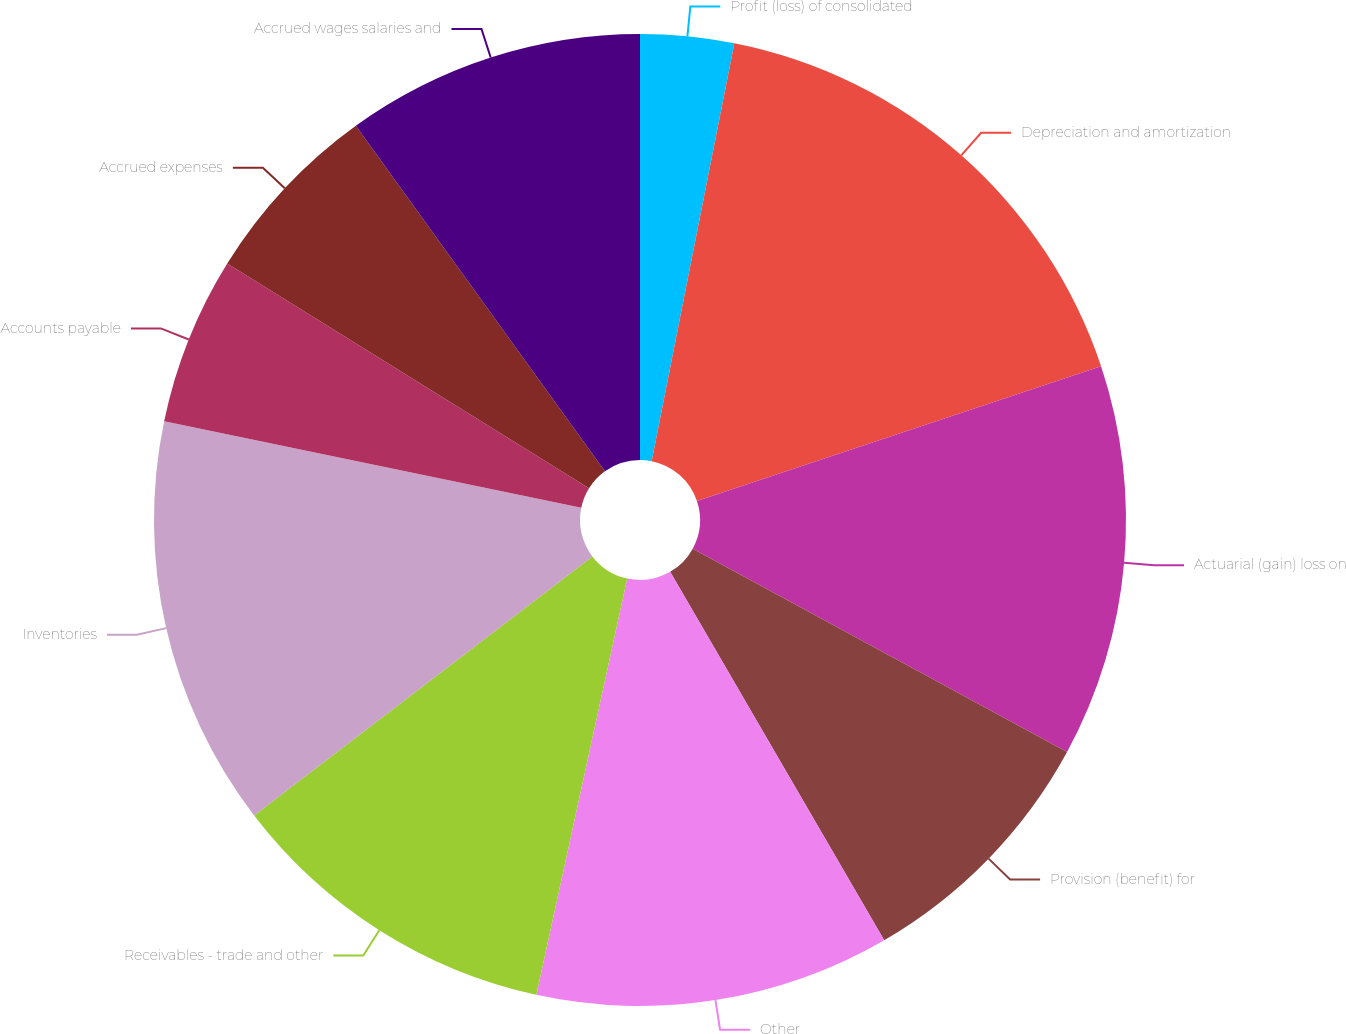Convert chart. <chart><loc_0><loc_0><loc_500><loc_500><pie_chart><fcel>Profit (loss) of consolidated<fcel>Depreciation and amortization<fcel>Actuarial (gain) loss on<fcel>Provision (benefit) for<fcel>Other<fcel>Receivables - trade and other<fcel>Inventories<fcel>Accounts payable<fcel>Accrued expenses<fcel>Accrued wages salaries and<nl><fcel>3.11%<fcel>16.77%<fcel>13.04%<fcel>8.7%<fcel>11.8%<fcel>11.18%<fcel>13.66%<fcel>5.59%<fcel>6.21%<fcel>9.94%<nl></chart> 